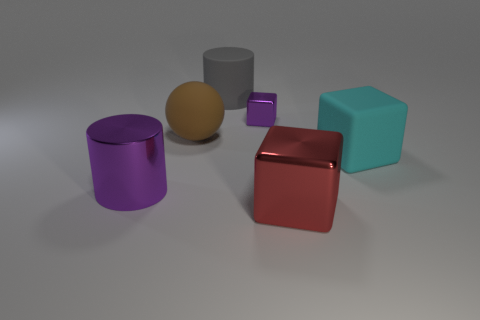Subtract all shiny blocks. How many blocks are left? 1 Add 3 tiny yellow blocks. How many objects exist? 9 Subtract all purple cubes. How many cubes are left? 2 Subtract 0 gray spheres. How many objects are left? 6 Subtract all cylinders. How many objects are left? 4 Subtract all green blocks. Subtract all purple cylinders. How many blocks are left? 3 Subtract all gray metal things. Subtract all rubber blocks. How many objects are left? 5 Add 1 matte objects. How many matte objects are left? 4 Add 4 purple metallic things. How many purple metallic things exist? 6 